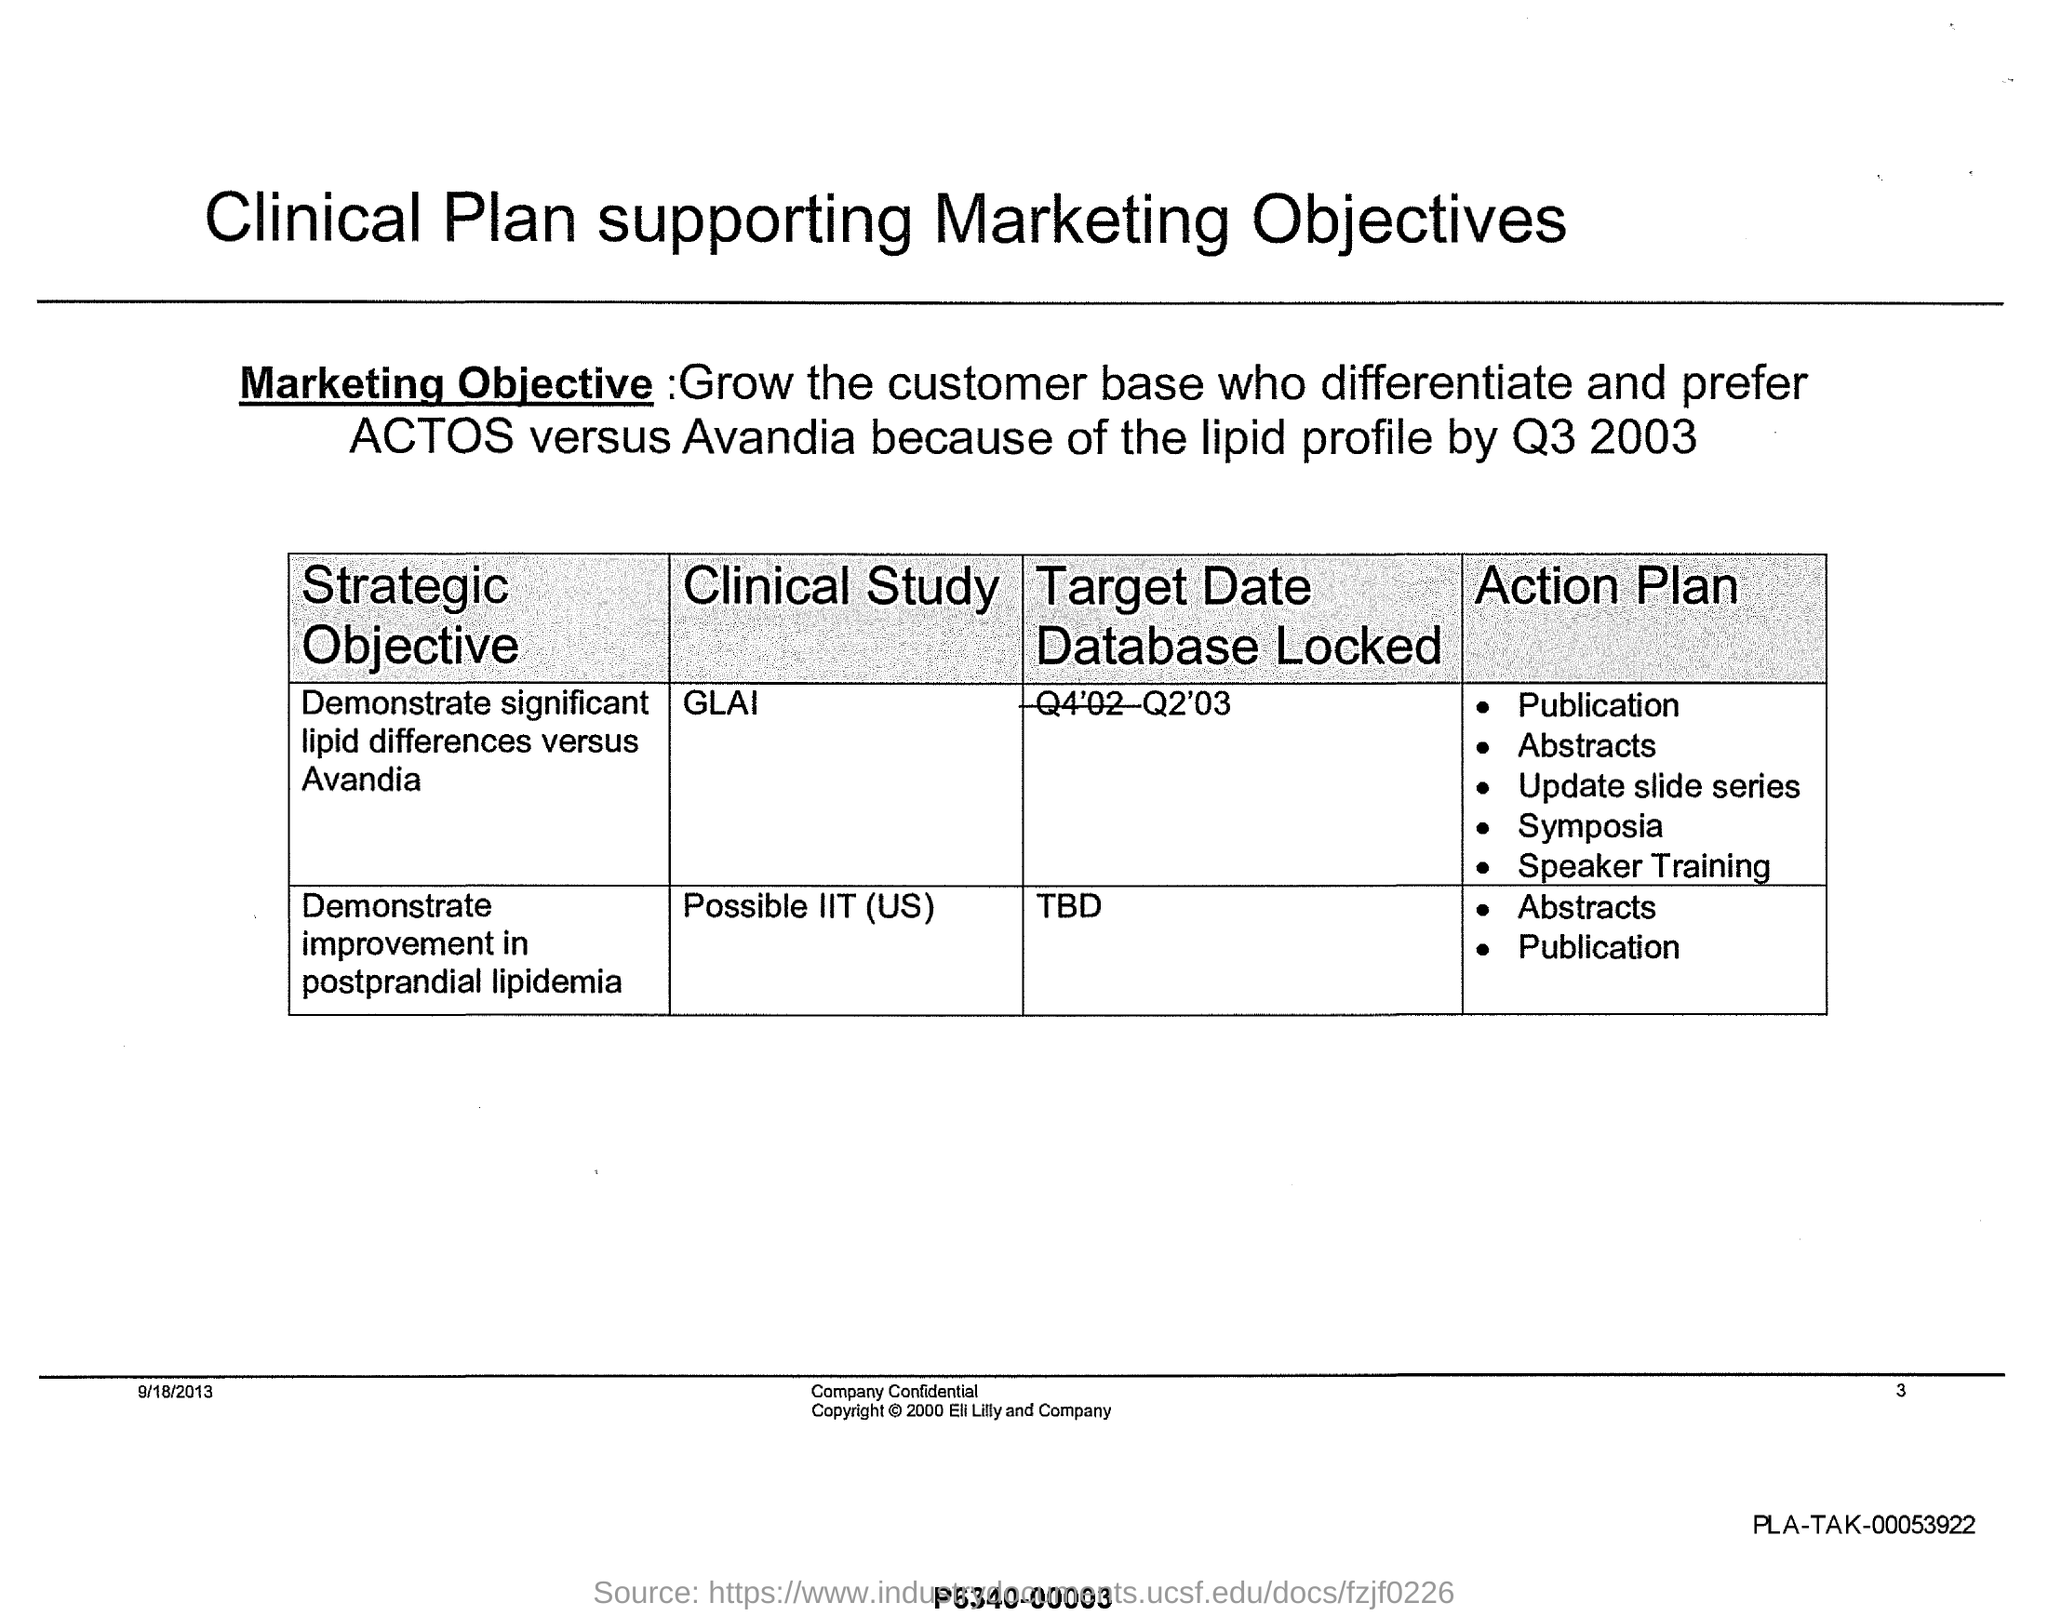Highlight a few significant elements in this photo. The strategic objective of the Clinical study 'GLAI' is to demonstrate significant lipid differences compared to Avandia. The strategic objective of the Clinical study "Possible IIT (US)" is to demonstrate improvement in postprandial lipidemia. The document does not specify the page number mentioned in it. The clinical study with a target date of Q2'03 has locked its database. The target date for locking the database for the clinical study "Possible IIT (US)" is currently unknown. 